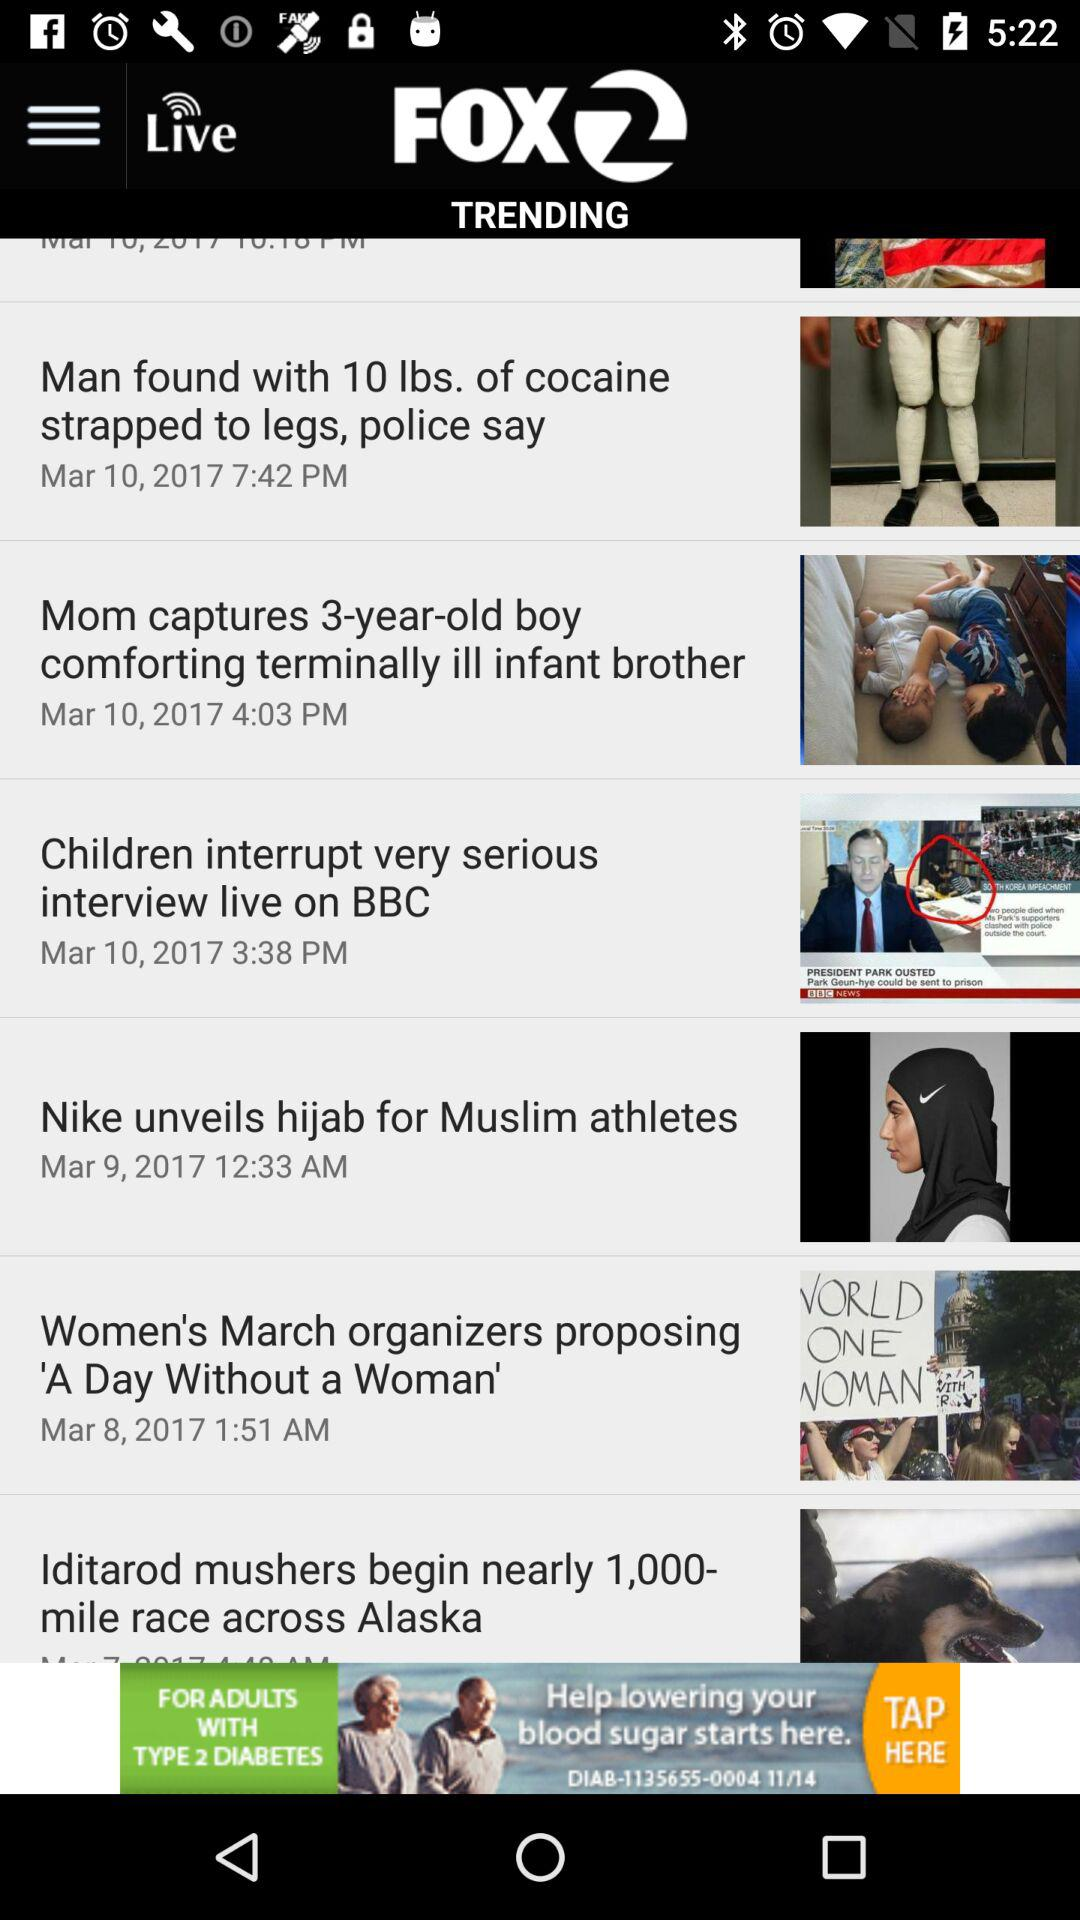What is the name of the application? The name of the application is "FOX 2". 